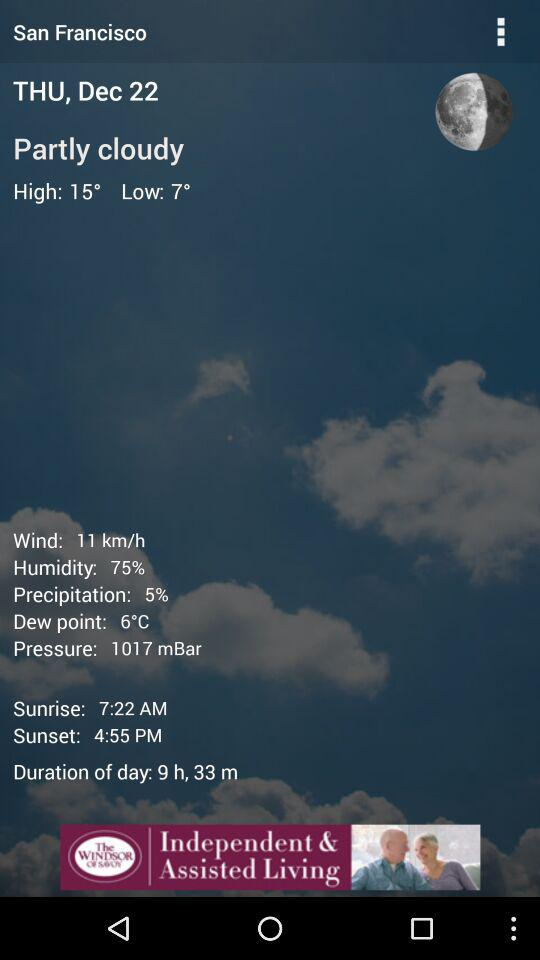In what unit is the wind measured? The wind is measured in km/h. 